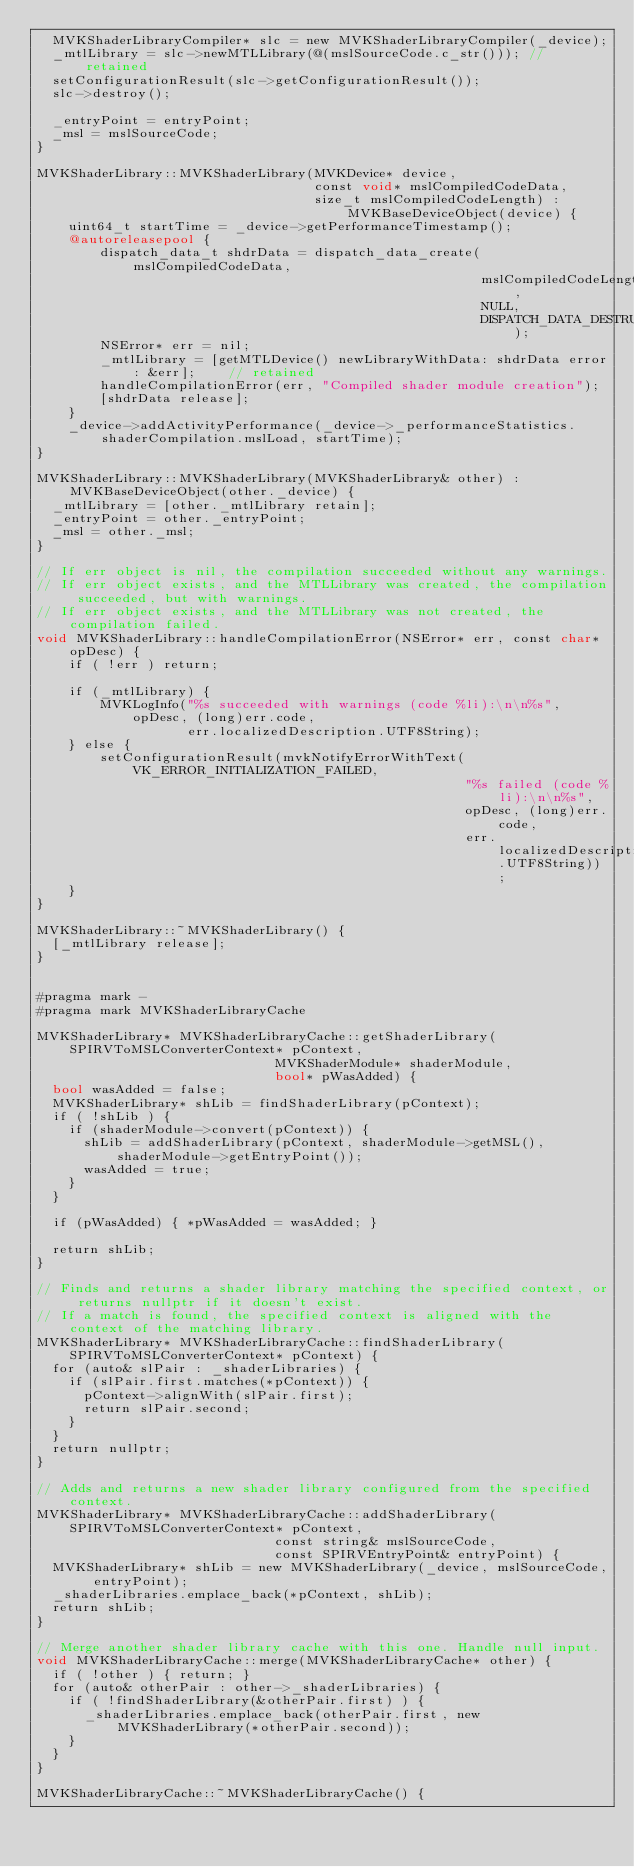Convert code to text. <code><loc_0><loc_0><loc_500><loc_500><_ObjectiveC_>	MVKShaderLibraryCompiler* slc = new MVKShaderLibraryCompiler(_device);
	_mtlLibrary = slc->newMTLLibrary(@(mslSourceCode.c_str()));	// retained
	setConfigurationResult(slc->getConfigurationResult());
	slc->destroy();

	_entryPoint = entryPoint;
	_msl = mslSourceCode;
}

MVKShaderLibrary::MVKShaderLibrary(MVKDevice* device,
                                   const void* mslCompiledCodeData,
                                   size_t mslCompiledCodeLength) : MVKBaseDeviceObject(device) {
    uint64_t startTime = _device->getPerformanceTimestamp();
    @autoreleasepool {
        dispatch_data_t shdrData = dispatch_data_create(mslCompiledCodeData,
                                                        mslCompiledCodeLength,
                                                        NULL,
                                                        DISPATCH_DATA_DESTRUCTOR_DEFAULT);
        NSError* err = nil;
        _mtlLibrary = [getMTLDevice() newLibraryWithData: shdrData error: &err];    // retained
        handleCompilationError(err, "Compiled shader module creation");
        [shdrData release];
    }
    _device->addActivityPerformance(_device->_performanceStatistics.shaderCompilation.mslLoad, startTime);
}

MVKShaderLibrary::MVKShaderLibrary(MVKShaderLibrary& other) : MVKBaseDeviceObject(other._device) {
	_mtlLibrary = [other._mtlLibrary retain];
	_entryPoint = other._entryPoint;
	_msl = other._msl;
}

// If err object is nil, the compilation succeeded without any warnings.
// If err object exists, and the MTLLibrary was created, the compilation succeeded, but with warnings.
// If err object exists, and the MTLLibrary was not created, the compilation failed.
void MVKShaderLibrary::handleCompilationError(NSError* err, const char* opDesc) {
    if ( !err ) return;

    if (_mtlLibrary) {
        MVKLogInfo("%s succeeded with warnings (code %li):\n\n%s", opDesc, (long)err.code,
                   err.localizedDescription.UTF8String);
    } else {
        setConfigurationResult(mvkNotifyErrorWithText(VK_ERROR_INITIALIZATION_FAILED,
                                                      "%s failed (code %li):\n\n%s",
                                                      opDesc, (long)err.code,
                                                      err.localizedDescription.UTF8String));
    }
}

MVKShaderLibrary::~MVKShaderLibrary() {
	[_mtlLibrary release];
}


#pragma mark -
#pragma mark MVKShaderLibraryCache

MVKShaderLibrary* MVKShaderLibraryCache::getShaderLibrary(SPIRVToMSLConverterContext* pContext,
														  MVKShaderModule* shaderModule,
														  bool* pWasAdded) {
	bool wasAdded = false;
	MVKShaderLibrary* shLib = findShaderLibrary(pContext);
	if ( !shLib ) {
		if (shaderModule->convert(pContext)) {
			shLib = addShaderLibrary(pContext, shaderModule->getMSL(), shaderModule->getEntryPoint());
			wasAdded = true;
		}
	}

	if (pWasAdded) { *pWasAdded = wasAdded; }

	return shLib;
}

// Finds and returns a shader library matching the specified context, or returns nullptr if it doesn't exist.
// If a match is found, the specified context is aligned with the context of the matching library.
MVKShaderLibrary* MVKShaderLibraryCache::findShaderLibrary(SPIRVToMSLConverterContext* pContext) {
	for (auto& slPair : _shaderLibraries) {
		if (slPair.first.matches(*pContext)) {
			pContext->alignWith(slPair.first);
			return slPair.second;
		}
	}
	return nullptr;
}

// Adds and returns a new shader library configured from the specified context.
MVKShaderLibrary* MVKShaderLibraryCache::addShaderLibrary(SPIRVToMSLConverterContext* pContext,
														  const string& mslSourceCode,
														  const SPIRVEntryPoint& entryPoint) {
	MVKShaderLibrary* shLib = new MVKShaderLibrary(_device, mslSourceCode, entryPoint);
	_shaderLibraries.emplace_back(*pContext, shLib);
	return shLib;
}

// Merge another shader library cache with this one. Handle null input.
void MVKShaderLibraryCache::merge(MVKShaderLibraryCache* other) {
	if ( !other ) { return; }
	for (auto& otherPair : other->_shaderLibraries) {
		if ( !findShaderLibrary(&otherPair.first) ) {
			_shaderLibraries.emplace_back(otherPair.first, new MVKShaderLibrary(*otherPair.second));
		}
	}
}

MVKShaderLibraryCache::~MVKShaderLibraryCache() {</code> 